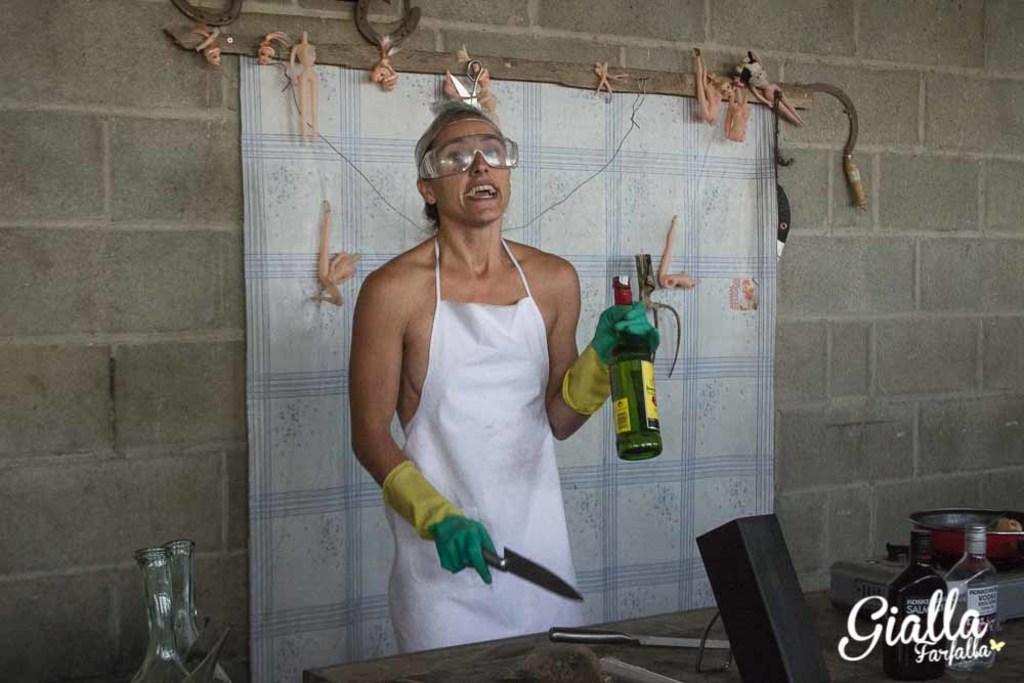Please provide a concise description of this image. In the picture we can find a person standing and holding a knife. She wore a gloved hand holding a bottle. In the background we can find a curtain attached to the wall. And we can see a table in front of the person. On the table we can find a knife, two bottles and box, a pan. 